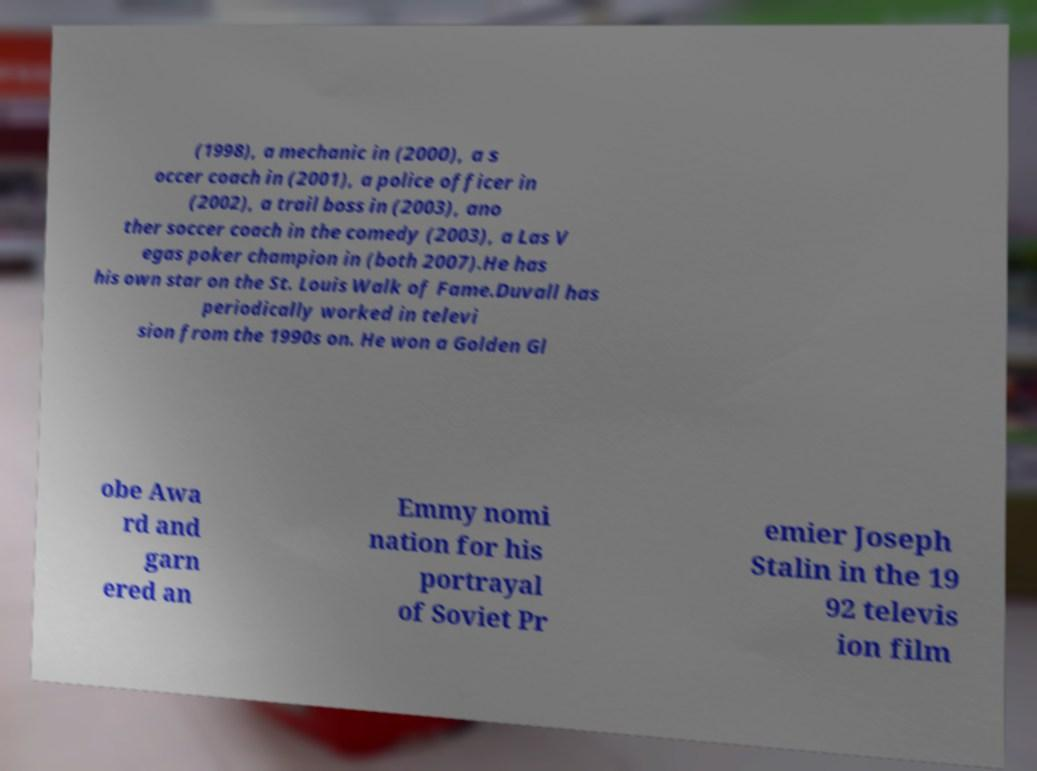Please read and relay the text visible in this image. What does it say? (1998), a mechanic in (2000), a s occer coach in (2001), a police officer in (2002), a trail boss in (2003), ano ther soccer coach in the comedy (2003), a Las V egas poker champion in (both 2007).He has his own star on the St. Louis Walk of Fame.Duvall has periodically worked in televi sion from the 1990s on. He won a Golden Gl obe Awa rd and garn ered an Emmy nomi nation for his portrayal of Soviet Pr emier Joseph Stalin in the 19 92 televis ion film 